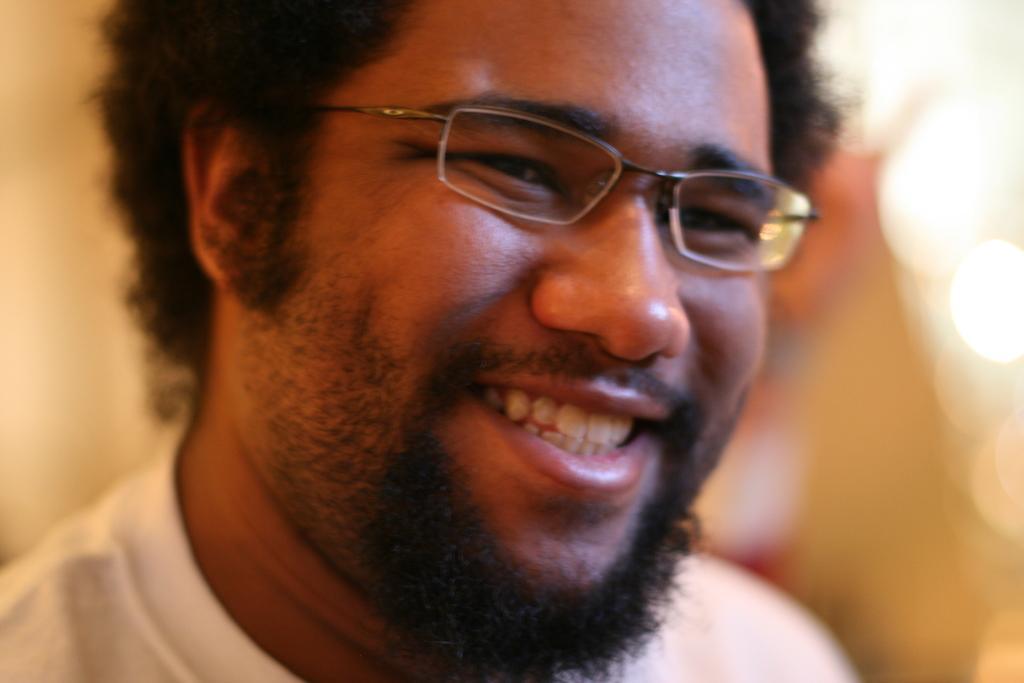How would you summarize this image in a sentence or two? There is a man in the center of the image wearing glasses and the background is blurry. 